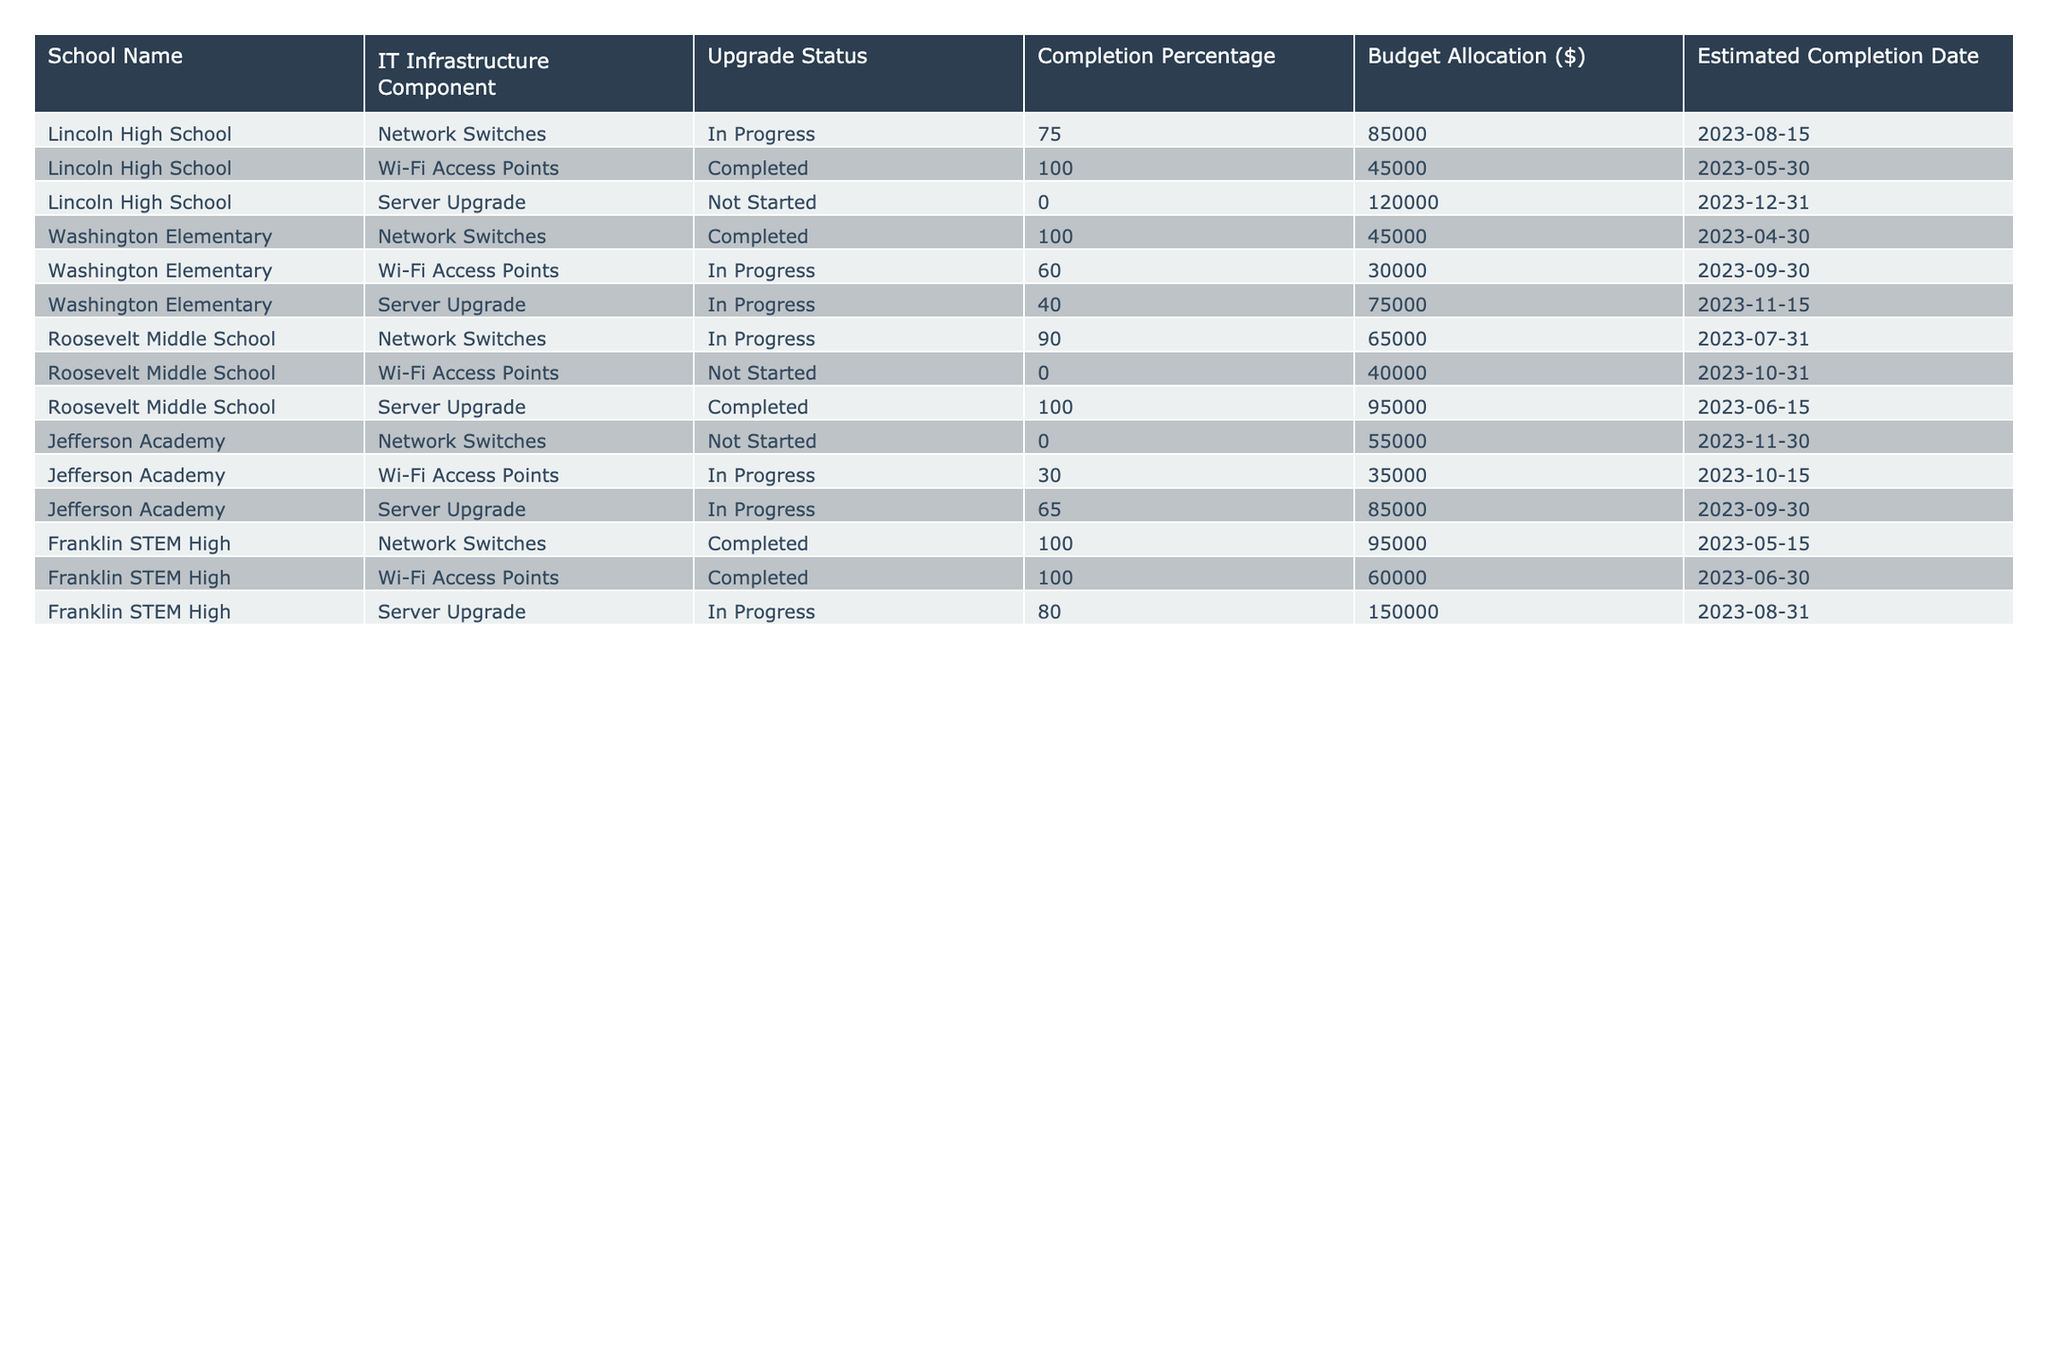What is the upgrade status of the Wi-Fi Access Points at Jefferson Academy? The table directly states the current upgrade status of Wi-Fi Access Points at Jefferson Academy, which is "In Progress."
Answer: In Progress Which school has the highest completion percentage for IT infrastructure upgrades? By examining the completion percentages in the table, Lincoln High School's Wi-Fi Access Points show the highest percentage at 100%.
Answer: Lincoln High School What is the budget allocation for the Server Upgrade at Washington Elementary? The budget allocation for the Server Upgrade at Washington Elementary is listed in the table as $75,000.
Answer: $75,000 How many schools have completed the upgrade for Network Switches? The table lists 4 schools, out of which Lincoln High School, Washington Elementary, Franklin STEM High, and Roosevelt Middle School completed their upgrades for Network Switches. Therefore, the total is 3.
Answer: 3 What is the estimated completion date for the Server Upgrade at Lincoln High School? According to the table, the estimated completion date for the Server Upgrade at Lincoln High School is December 31, 2023.
Answer: December 31, 2023 Which school has the earliest estimated completion date for any IT infrastructure component? Upon reviewing the estimated completion dates, Washington Elementary's Network Switches shows the earliest date of April 30, 2023.
Answer: Washington Elementary What is the average completion percentage for Server Upgrades across all schools? The completion percentages for Server Upgrades are 0, 40, 100, 65, and 80 for the respective schools. Adding them gives 285, and averaging by dividing by 5 results in 57%.
Answer: 57% Is there any school where both Wi-Fi Access Points and Server Upgrade are completed? By checking the table, Franklin STEM High shows both Wi-Fi Access Points and Server Upgrade completed. Therefore, the answer is YES.
Answer: Yes What is the sum of the budget allocations for IT Infrastructure upgrades at Roosevelt Middle School? The budget allocations for Roosevelt Middle School are $65,000 for Network Switches, $40,000 for Wi-Fi Access Points, and $95,000 for Server Upgrade. Adding these together gives $200,000.
Answer: $200,000 How many total IT infrastructure components are listed for Franklin STEM High? The table highlights 3 IT infrastructure components: Network Switches, Wi-Fi Access Points, and Server Upgrade for Franklin STEM High. Thus, the total is 3.
Answer: 3 